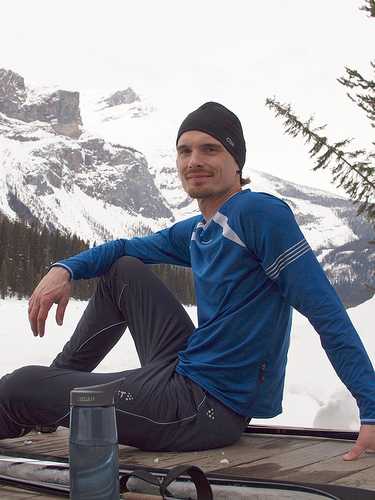<image>
Is the sky behind the mountain? Yes. From this viewpoint, the sky is positioned behind the mountain, with the mountain partially or fully occluding the sky. 